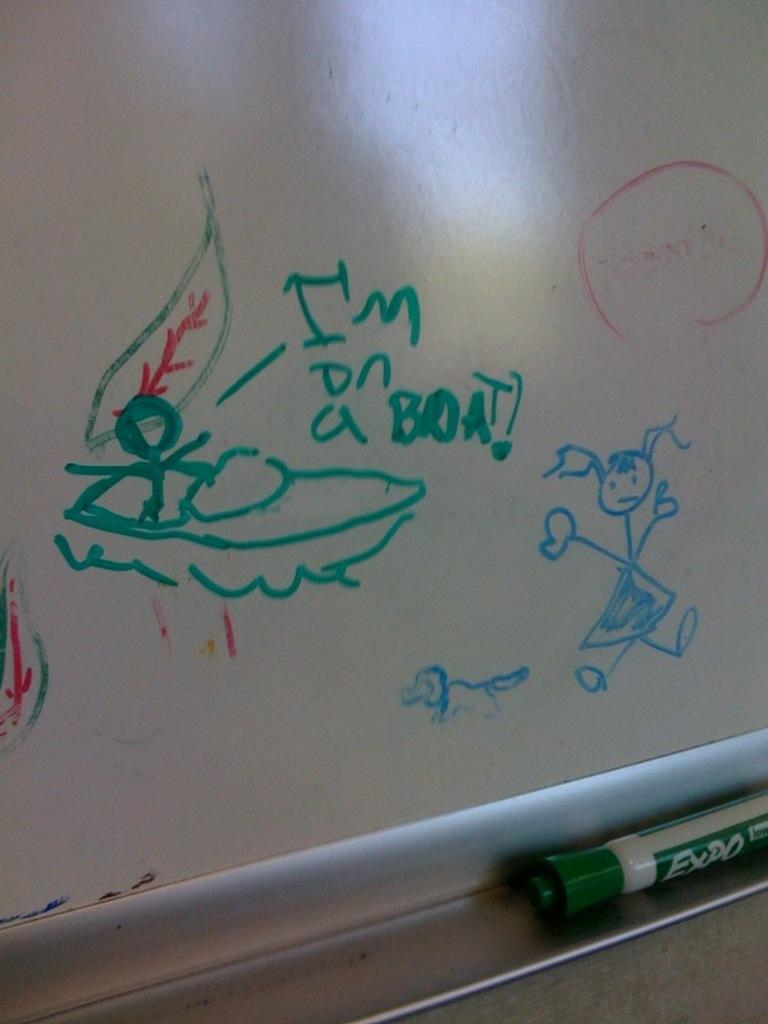<image>
Share a concise interpretation of the image provided. Whiteboard showing a person on a boat and the words "I'm on a boat". 